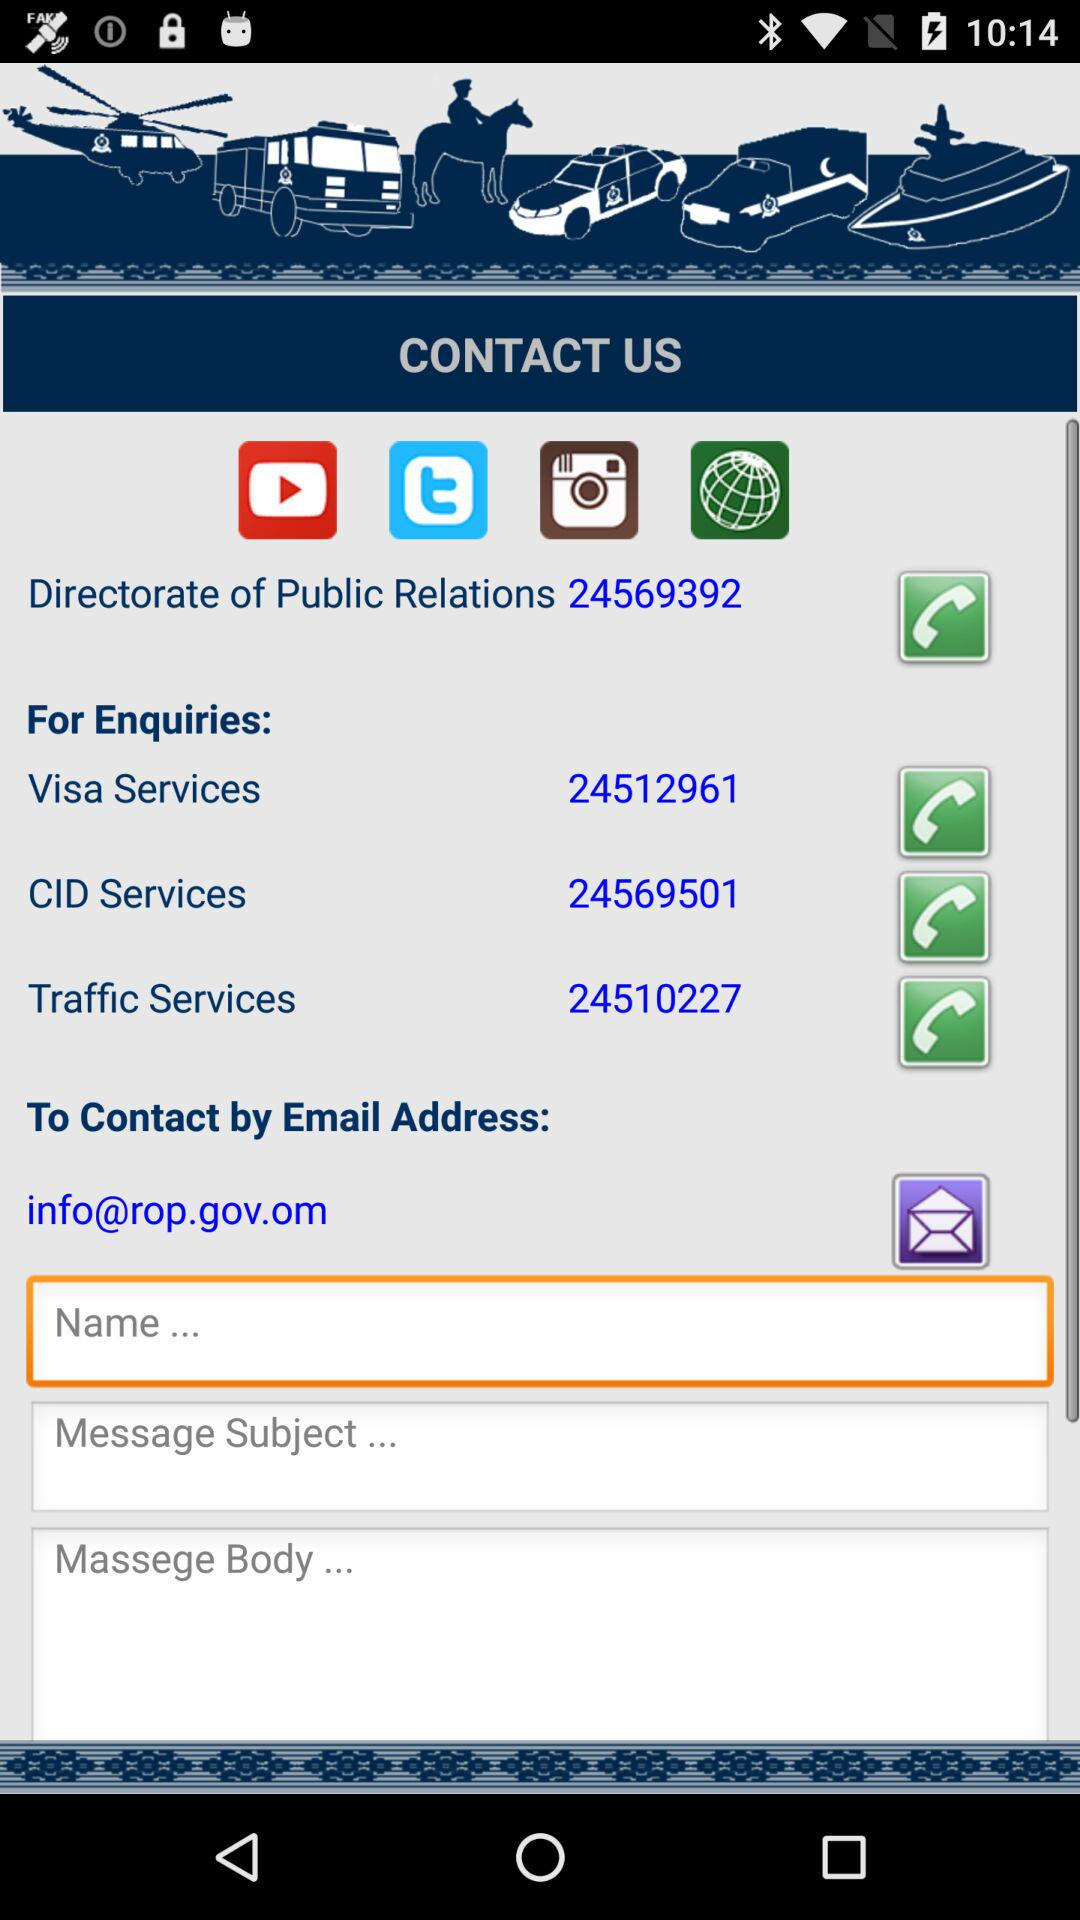How many text fields are there in the contact us section?
Answer the question using a single word or phrase. 3 